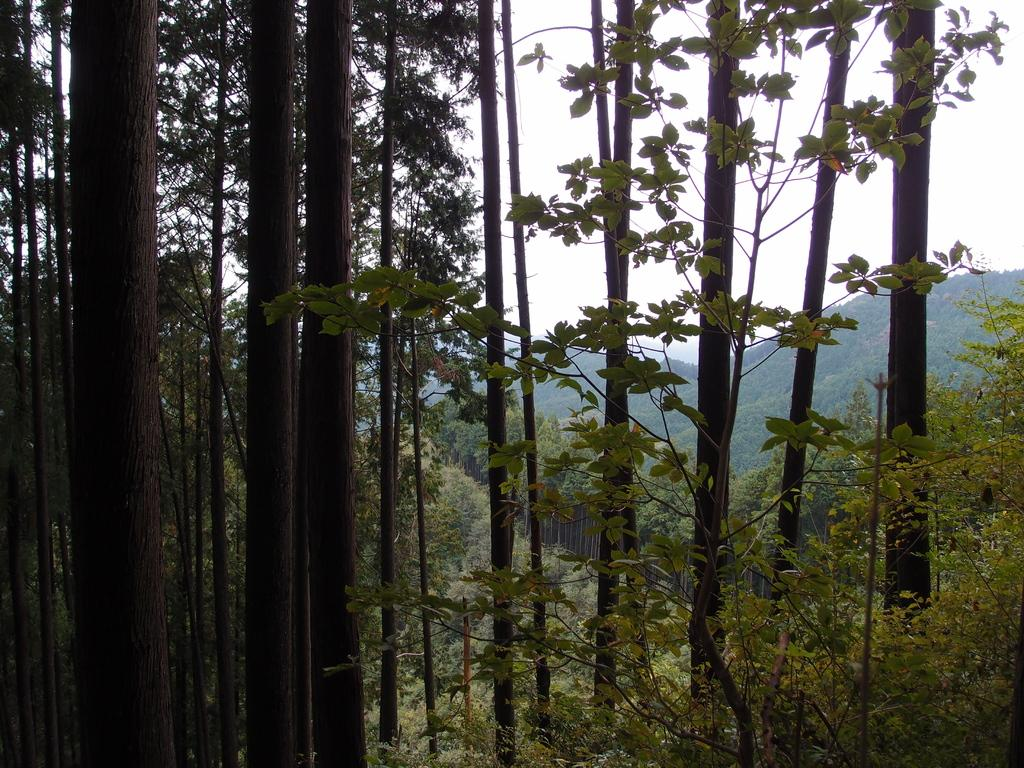What type of natural features can be seen in the image? There are trees and mountains in the image. What is visible in the background of the image? The sky is visible in the background of the image. Are there any police officers visible in the image? No, there are no police officers present in the image. What type of clouds can be seen in the sky in the image? The provided facts do not mention any clouds in the sky, so we cannot determine the type of clouds present. 